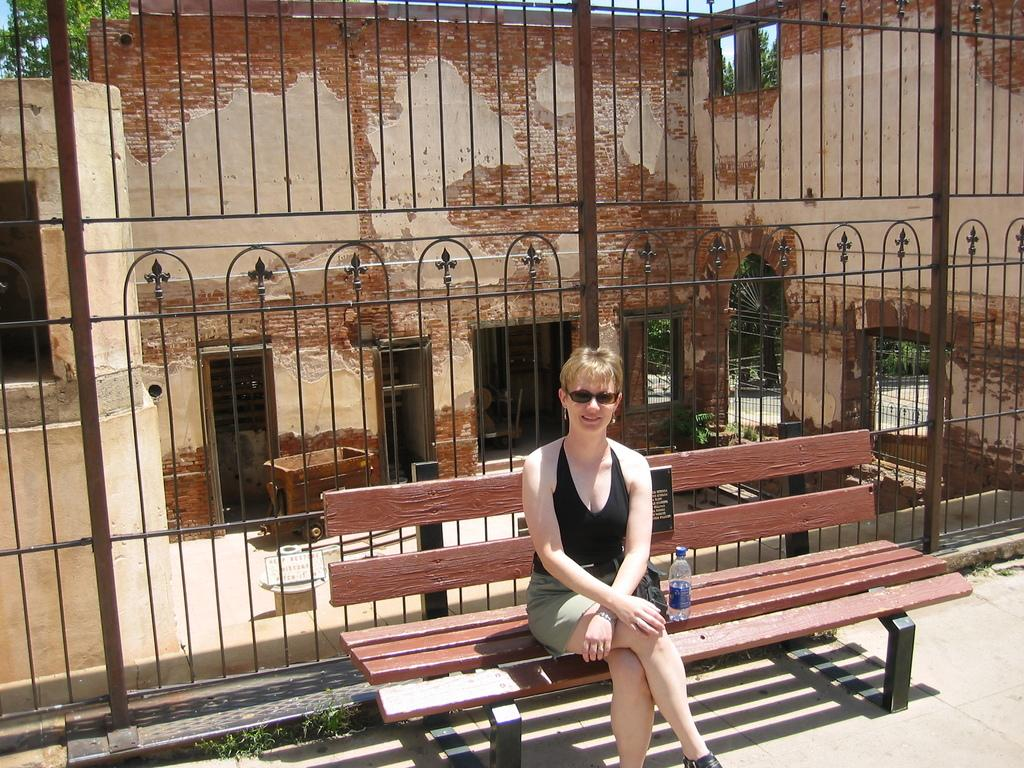What is the woman in the image doing? The woman is sitting on a bench in the image. What object can be seen near the woman? There is a bottle in the image. What can be seen in the distance behind the woman? There is a building and a tree in the background of the image. What type of question is the woman holding in the image? There is no question visible in the image; the woman is simply sitting on a bench. 